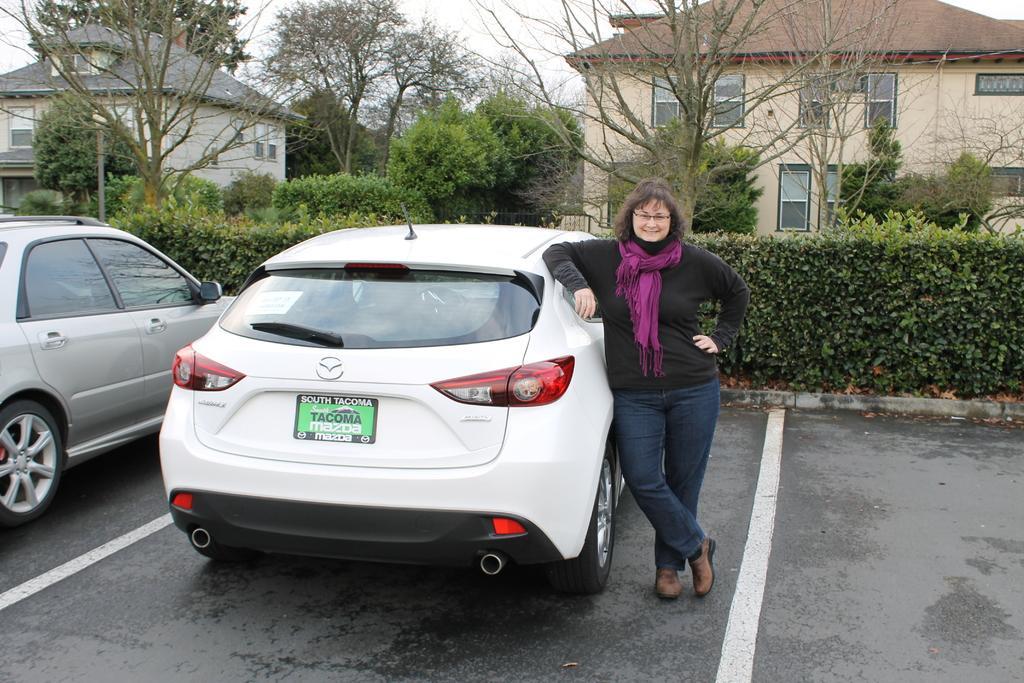Can you describe this image briefly? In the image in the center we can see one woman standing and she is smiling,which we can see on her face. And we can see two cars on the road. In the background we can see trees,sky,clouds,buildings,roof,wall,windows,fence,plants etc. 